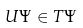<formula> <loc_0><loc_0><loc_500><loc_500>U \Psi \in T \Psi</formula> 